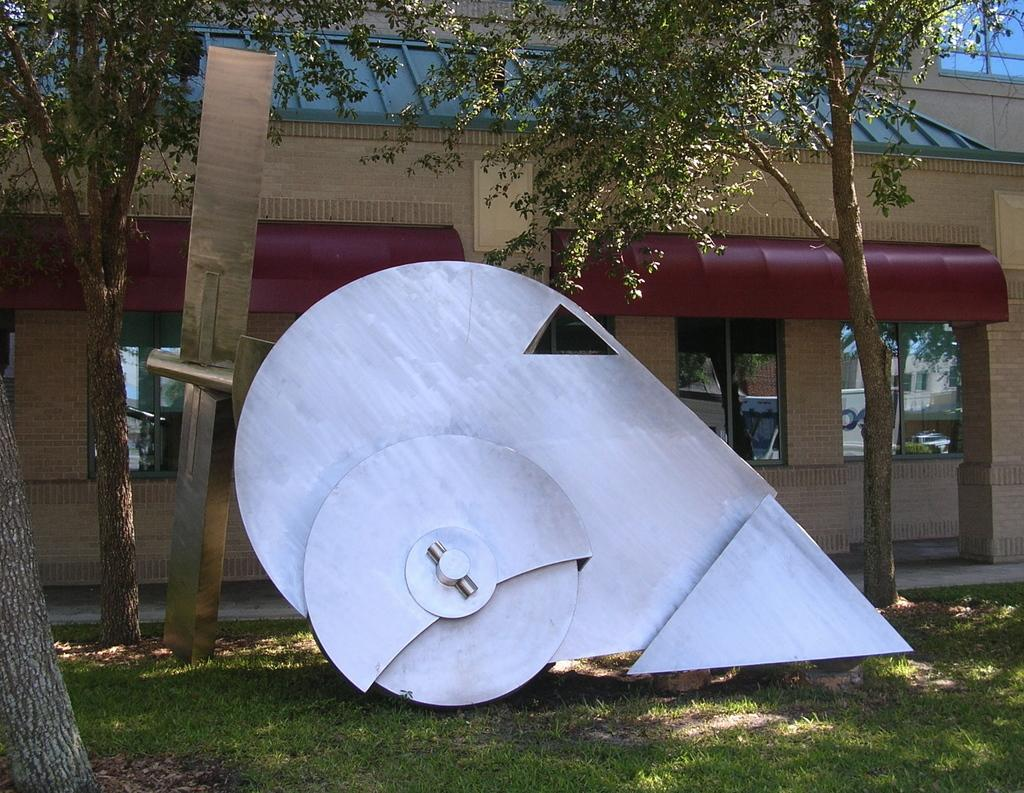What type of structure is located in the middle of the image? There is a wooden architecture in the middle of the image. Where is the wooden architecture situated? The wooden architecture is on the grass. What can be seen in the background of the image? There are trees and a building in the background of the image. What type of grip can be seen on the wooden architecture in the image? There is no specific grip visible on the wooden architecture in the image. 